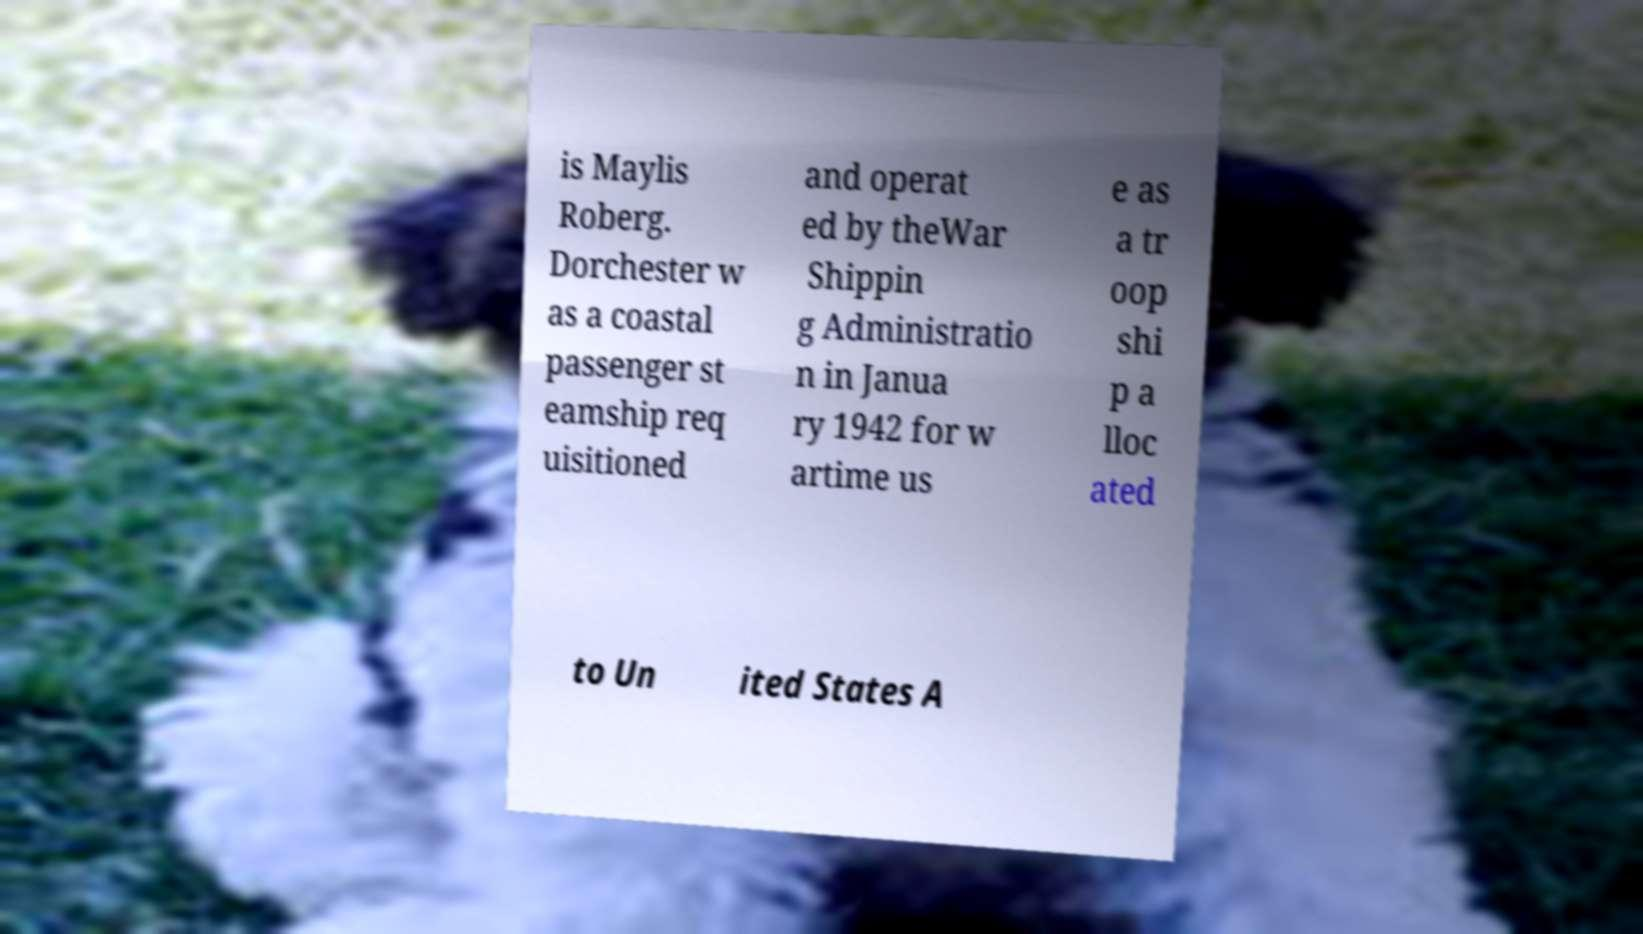There's text embedded in this image that I need extracted. Can you transcribe it verbatim? is Maylis Roberg. Dorchester w as a coastal passenger st eamship req uisitioned and operat ed by theWar Shippin g Administratio n in Janua ry 1942 for w artime us e as a tr oop shi p a lloc ated to Un ited States A 